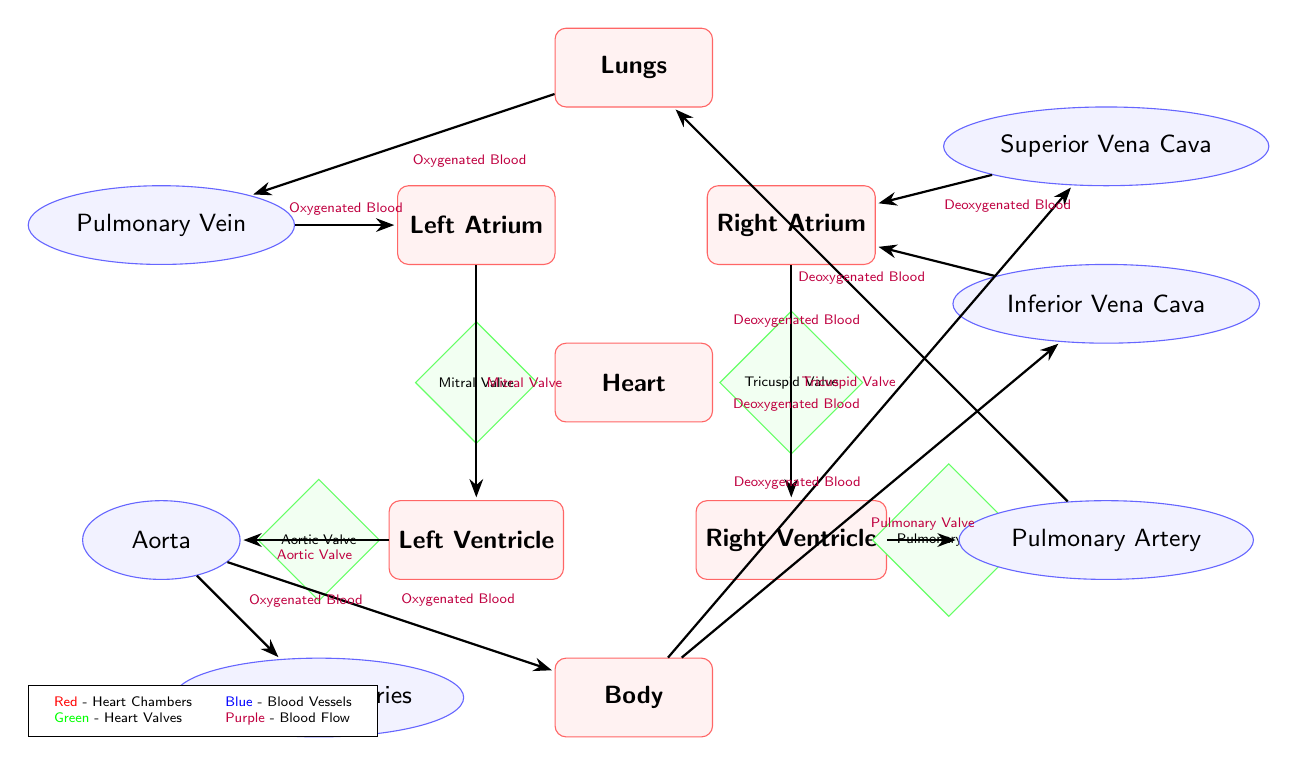How many heart chambers are depicted in the diagram? The diagram shows four distinct heart chambers: Left Atrium, Left Ventricle, Right Atrium, and Right Ventricle. By counting the labeled organ nodes related to the heart within the diagram, we confirm there are four chambers in total.
Answer: 4 What is the function of the Mitral Valve? The Mitral Valve is positioned between the Left Atrium and the Left Ventricle, allowing blood flow from the atrium to the ventricle while preventing backflow into the atrium. It plays a crucial role during the cardiac cycle when the heart pumps blood to the body.
Answer: Preventing backflow Which vessel carries oxygenated blood away from the heart? The Aorta is designated in the diagram as the main vessel that carries oxygenated blood away from the Left Ventricle to distribute it throughout the body. This is evident from the flow arrows indicating the direction of blood from the Aorta to the Body.
Answer: Aorta What type of blood returns to the right atrium of the heart? The diagram shows Deoxygenated Blood entering the Right Atrium from both the Superior and Inferior Vena Cava. This information can be deduced by following the flow of blood represented with arrows leading into the Right Atrium from these vessels.
Answer: Deoxygenated Blood How many valves are illustrated in the diagram? The diagram depicts four heart valves: Mitral Valve, Tricuspid Valve, Aortic Valve, and Pulmonary Valve. By locating each valve represented as a diamond shape in the diagram, we count these distinct structures to arrive at the total.
Answer: 4 What flow direction is observed between the Pulmonary Artery and the Lungs? The flow direction between the Pulmonary Artery and the Lungs is labeled as "Deoxygenated Blood," indicating that this vessel transports blood low in oxygen to the lungs for oxygenation. The flow arrows confirm this directionality.
Answer: Deoxygenated Blood Where does the oxygenated blood flow after it leaves the lungs? After leaving the lungs, oxygenated blood flows into the Pulmonary Vein, as illustrated in the diagram by the arrow indicating flow from the Lungs to the Pulmonary Vein. This is a key step in the pulmonary circulation process.
Answer: Pulmonary Vein Which structure receives blood from the Coronary Arteries? The Coronary Arteries supply blood directly to the heart tissue, specifically the heart chambers. The diagram indicates that this blood supply is directed to the heart, distinguishing it from the systemic circulation.
Answer: Heart 